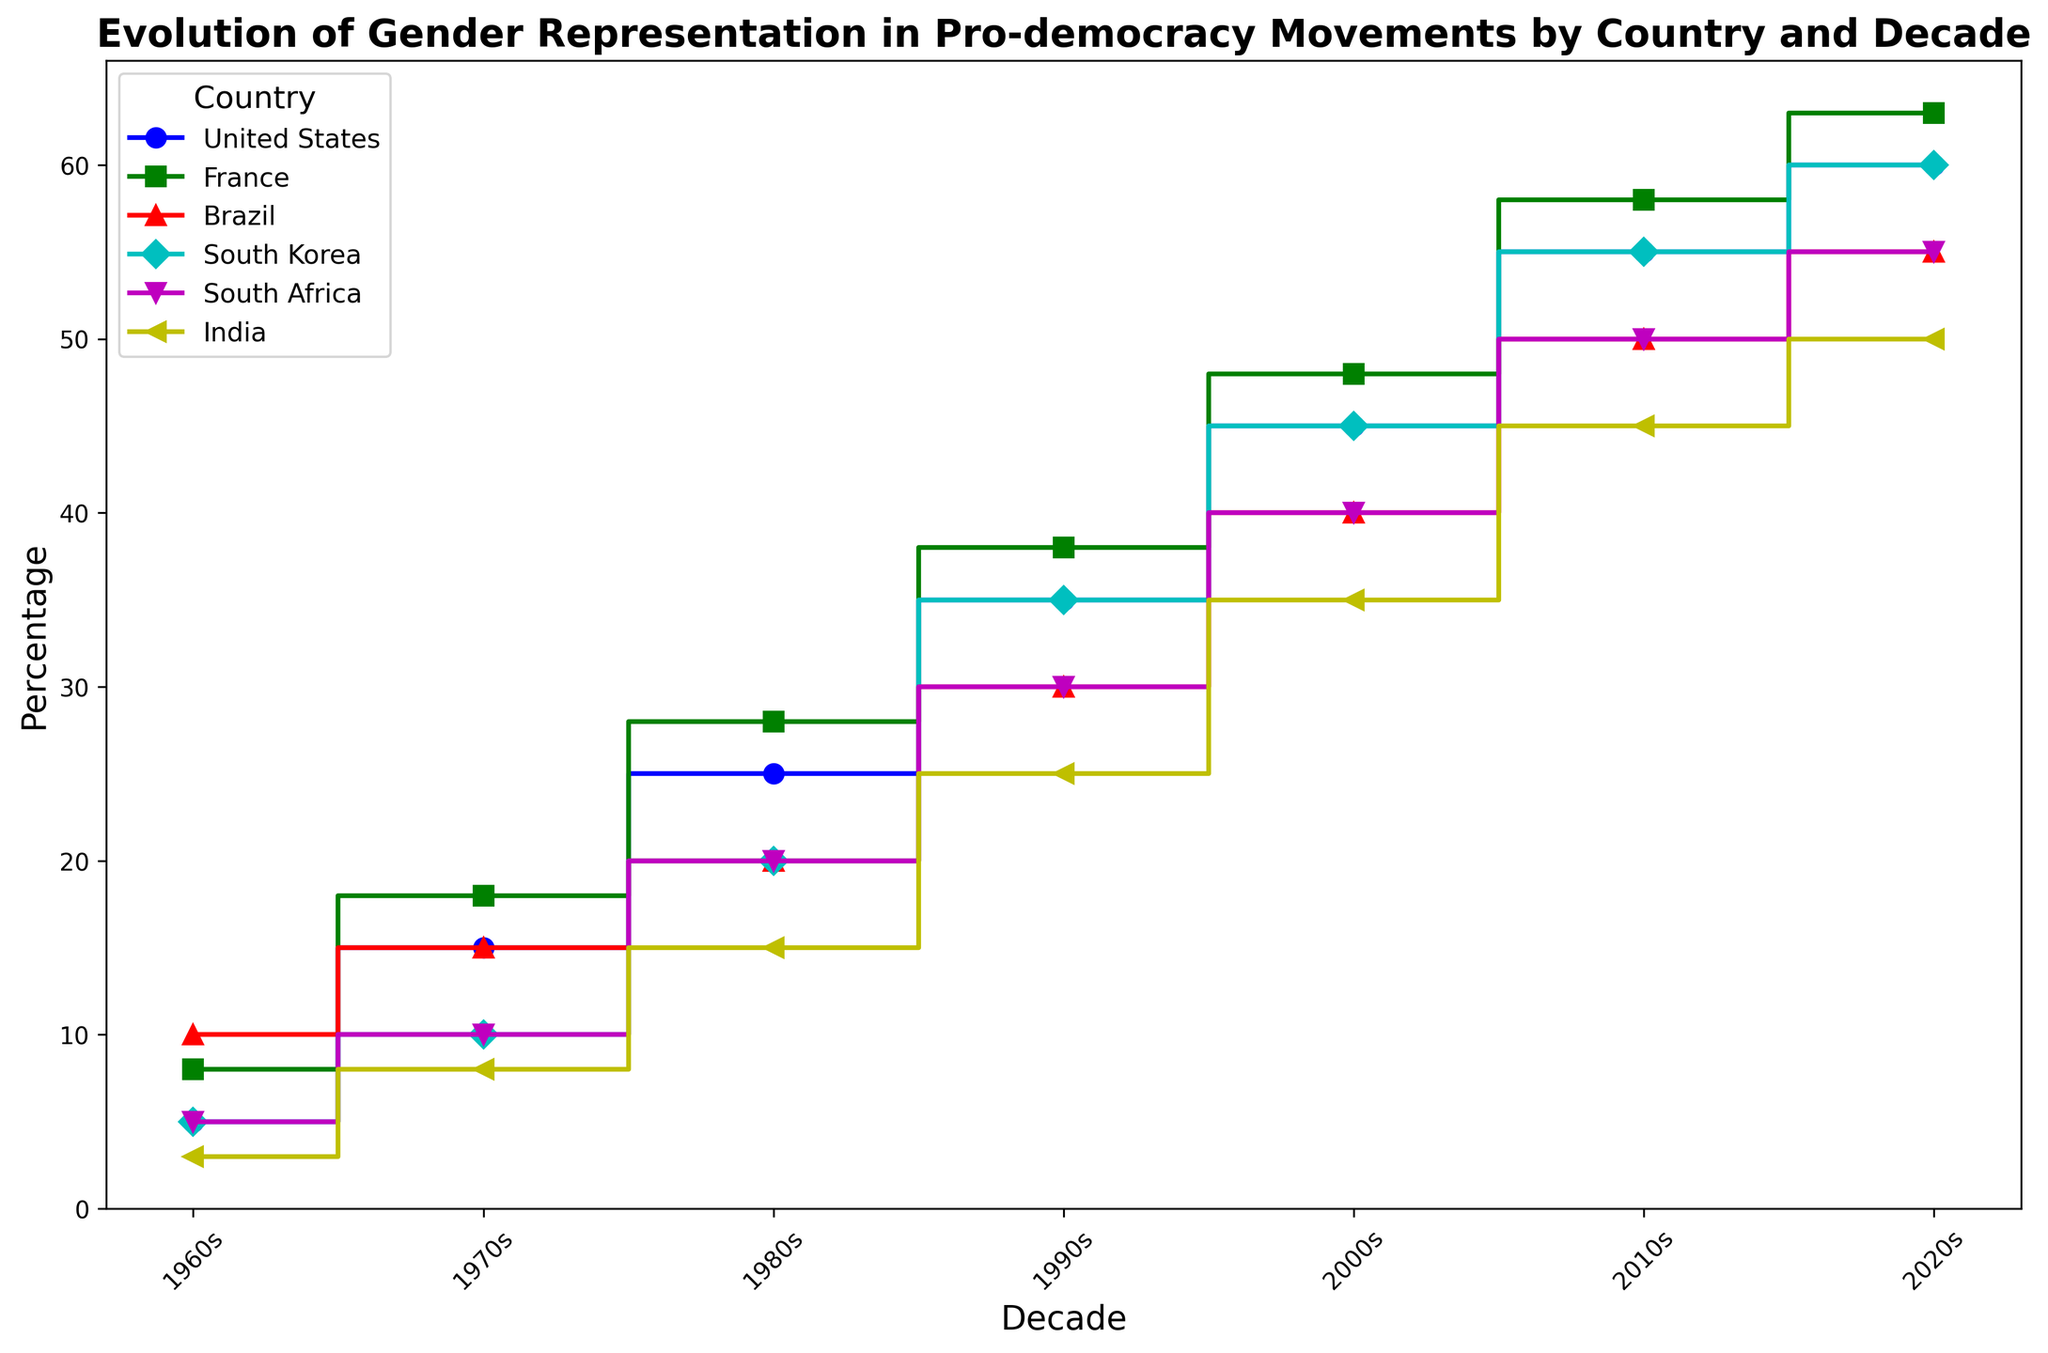What is the highest percentage of gender representation in the 2020s? Look for the highest point in the graph corresponding to the decade of the 2020s across all countries. The highest value is 63%, which is for France.
Answer: 63% Which country had the lowest gender representation in the 1960s? Check the values for each country in the 1960s. India had the lowest percentage, which is 3%.
Answer: India By how much did gender representation increase in the United States from the 1960s to the 2020s? Find the values for the United States in the 1960s and 2020s. Calculate the difference: 60% - 5% = 55%.
Answer: 55% Which two countries had equal gender representation in the 2020s? Look for countries with the same percentage in the 2020s. Both Brazil and South Africa had 55%.
Answer: Brazil and South Africa Compare the percentage increase in gender representation from the 1960s to the 2020s for India and South Korea. Which country had a higher increase? Calculate the increase for both countries from the 1960s to the 2020s. India: 50% - 3% = 47%, South Korea: 60% - 5% = 55%. South Korea had a higher increase.
Answer: South Korea Which decade saw the highest increase in gender representation in France compared to the previous decade? Calculate the differences between consecutive decades for France. The highest increase is from the 1960s to the 1970s, which is 18% - 8% = 10%.
Answer: 1960s to 1970s Are there any countries where gender representation did not change for two consecutive decades? If so, which country and which decades? Look for flat lines (no increase) in the plot within any country. Brazil did not change from the 1960s to the 1970s (both 10%).
Answer: Brazil (1960s to 1970s) What was the average gender representation across all countries in the 2000s? Add the percentages for the 2000s for each country and divide by the number of countries: (45%+48%+40%+45%+40%+35%) / 6 = 42.17%.
Answer: 42.17% 